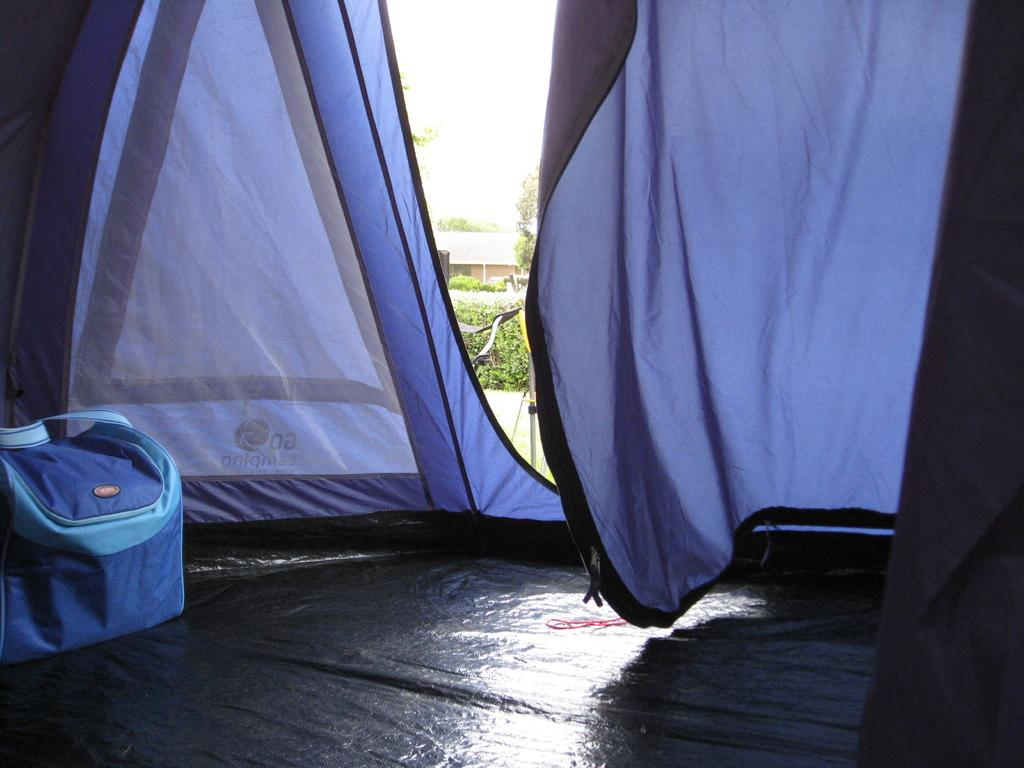What type of shelter is visible in the image? There is a tent in the image. What is inside the tent? There is a luggage bag inside the tent. What can be seen in the background of the image? There are trees visible in the image. What is located outside the tent? There is a vehicle outside the tent. Reasoning: Let's think step by step by following the facts step by step to create the conversation. We start by identifying the main subject, which is the tent. Then, we describe what is inside the tent and what can be seen in the background. Finally, we mention the vehicle located outside the tent. Each question is designed to provide specific details about the image based on the provided facts. Absurd Question/Answer: What type of meal is being prepared inside the tent? There is no indication of a meal being prepared inside the tent in the image. 